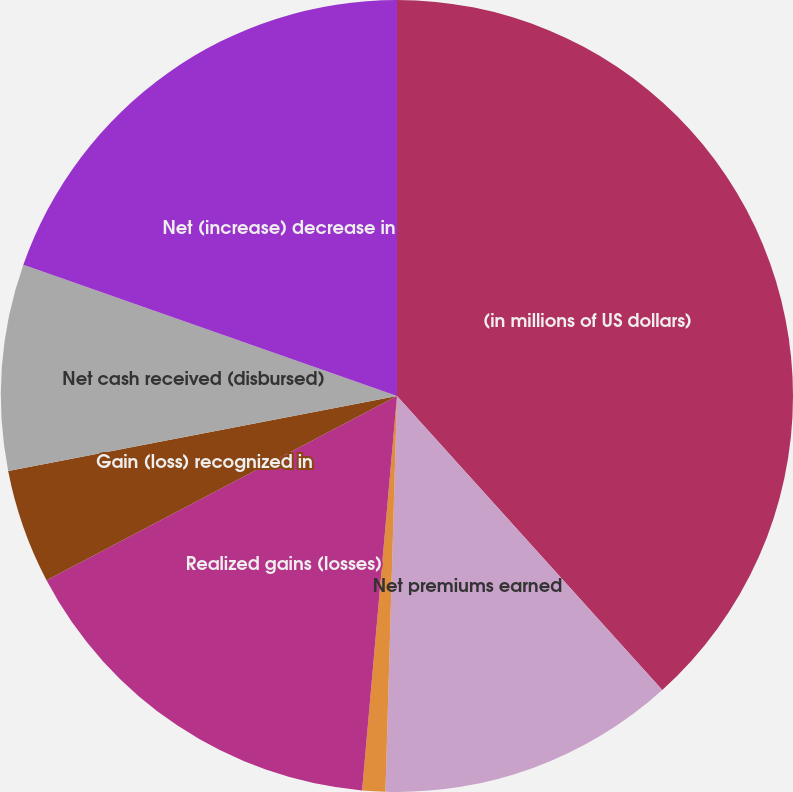<chart> <loc_0><loc_0><loc_500><loc_500><pie_chart><fcel>(in millions of US dollars)<fcel>Net premiums earned<fcel>Policy benefits<fcel>Realized gains (losses)<fcel>Gain (loss) recognized in<fcel>Net cash received (disbursed)<fcel>Net (increase) decrease in<nl><fcel>38.32%<fcel>12.15%<fcel>0.94%<fcel>15.89%<fcel>4.67%<fcel>8.41%<fcel>19.63%<nl></chart> 